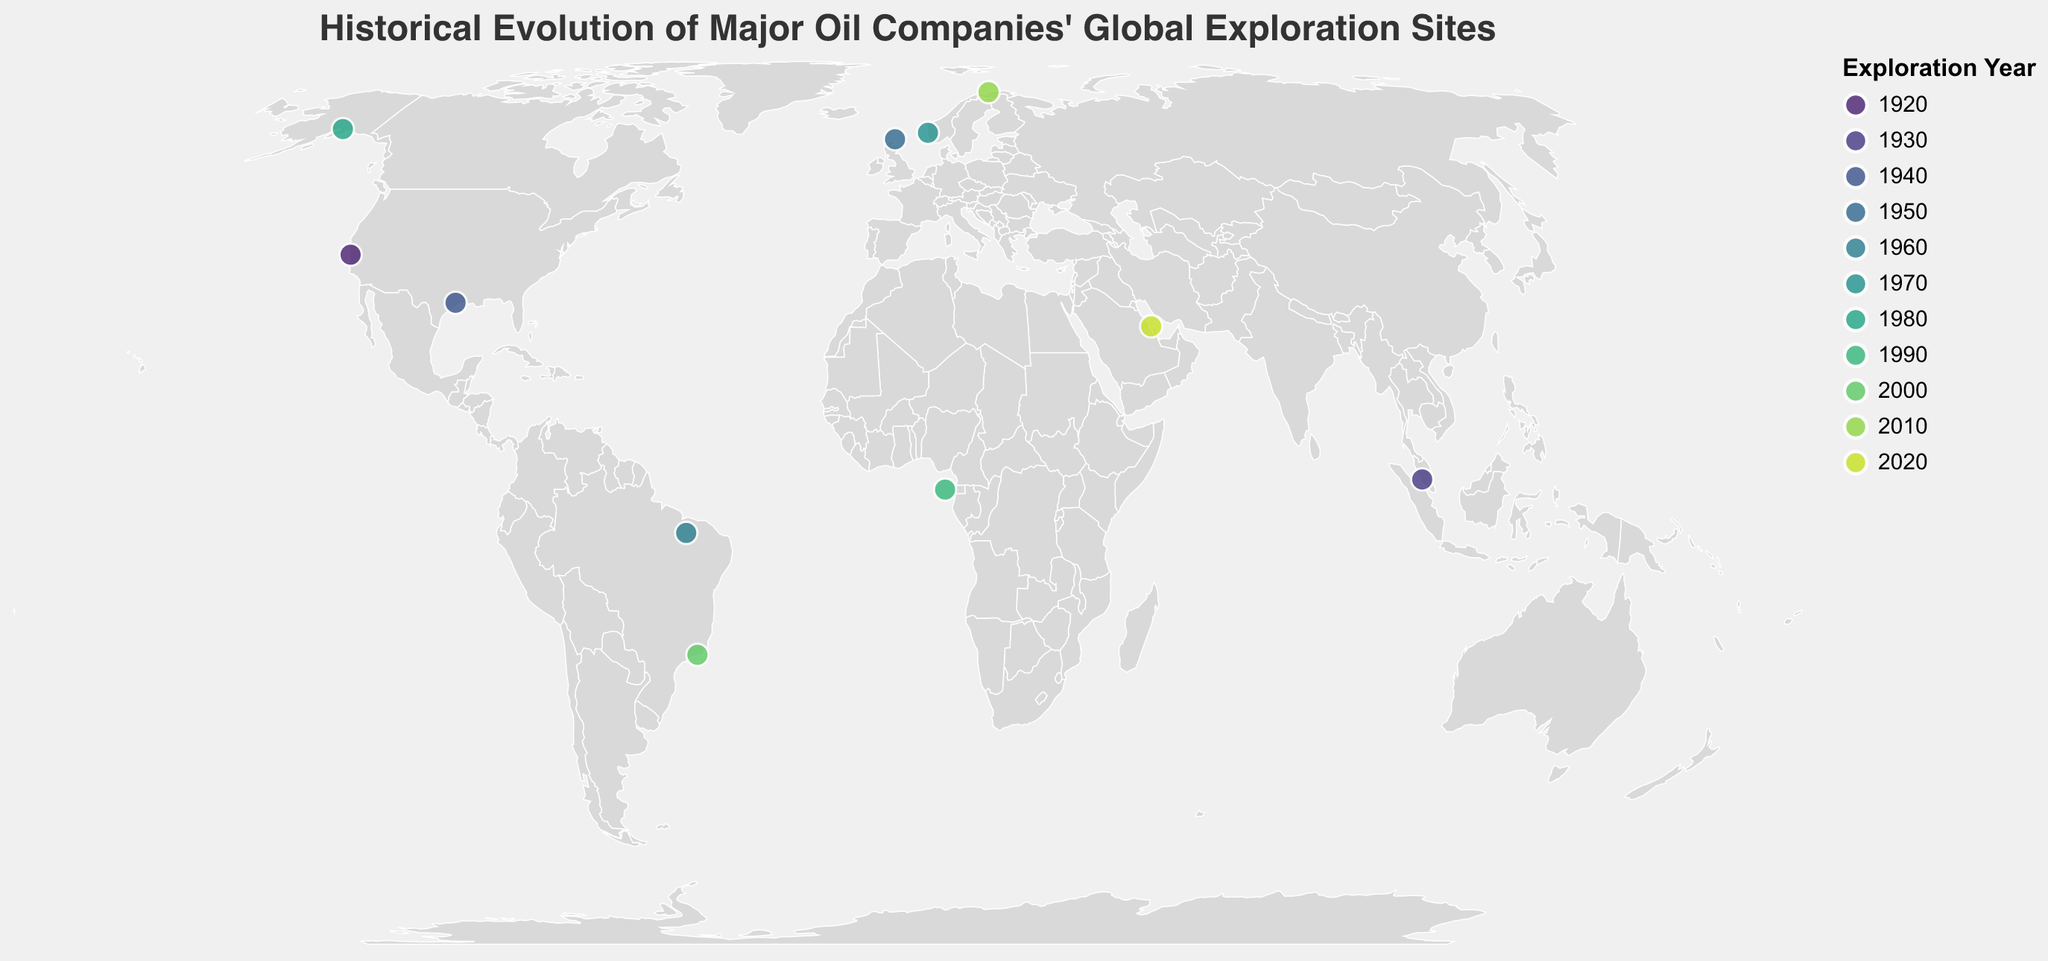what does the title of the figure indicate? The title of the figure is "Historical Evolution of Major Oil Companies' Global Exploration Sites", which indicates that the figure showcases the changes and development of global exploration sites by major oil companies over a historical timeline.
Answer: Historical Evolution of Major Oil Companies' Global Exploration Sites How many companies are represented in the figure? There are individual data points related to each oil company listed on the map. By counting the unique company names, we can identify 11 distinct companies.
Answer: 11 Which company explored the site in California? Referring to the geographic point and the tooltip information on the figure, the company that explored the site in California is Standard Oil.
Answer: Standard Oil What is the earliest exploration year shown in the figure? By examining the "Year" field attached to each exploration site, we see that the earliest year is 1920.
Answer: 1920 Which exploration site has the highest latitude? The latitude values indicate the north-south position. The Barents Sea Norway explored by Equinor in 2010 has the highest latitude of 70.6634.
Answer: Barents Sea Norway How many exploration sites are located in the Southern Hemisphere? Sites in the Southern Hemisphere have negative latitude values. According to the map, the sites explored by Chevron (Campos Basin Brazil) and Petrobras (Santos Basin Brazil) are located in the Southern Hemisphere.
Answer: 2 Which company had exploration sites in Brazil? By looking at the plotted geographic points within Brazil and checking their corresponding tooltips, both Chevron (Campos Basin) and Petrobras (Santos Basin) had exploration sites in Brazil.
Answer: Chevron and Petrobras What is the average longitude of the exploration sites discovered by 2000? To find the average longitude of sites discovered by 2000, sum the longitude values and divide by the number of sites up to 2000: (−122.3255 + 101.6869 − 95.3698 − 3.2889 − 43.8233 + 5.3221 − 149.9003 + 7.3826 − 43.1729) / 9 = −34.16565.
Answer: −34.16565 Which two companies have exploration sites closest to each other geographically? By comparing the geographic coordinates, the exploration sites of Chevron (Campos Basin Brazil) and Petrobras (Santos Basin Brazil) are geographically closest due to their locations both being in Brazil.
Answer: Chevron and Petrobras In which decade did the majority of the represented companies begin exploration? The figure shows one exploration site per company, with the year of exploration indicated. Analyzing the histogram of these years indicates that the majority began in different decades spread out, peaking in 1980 with ConocoPhillips' exploration.
Answer: 1980 